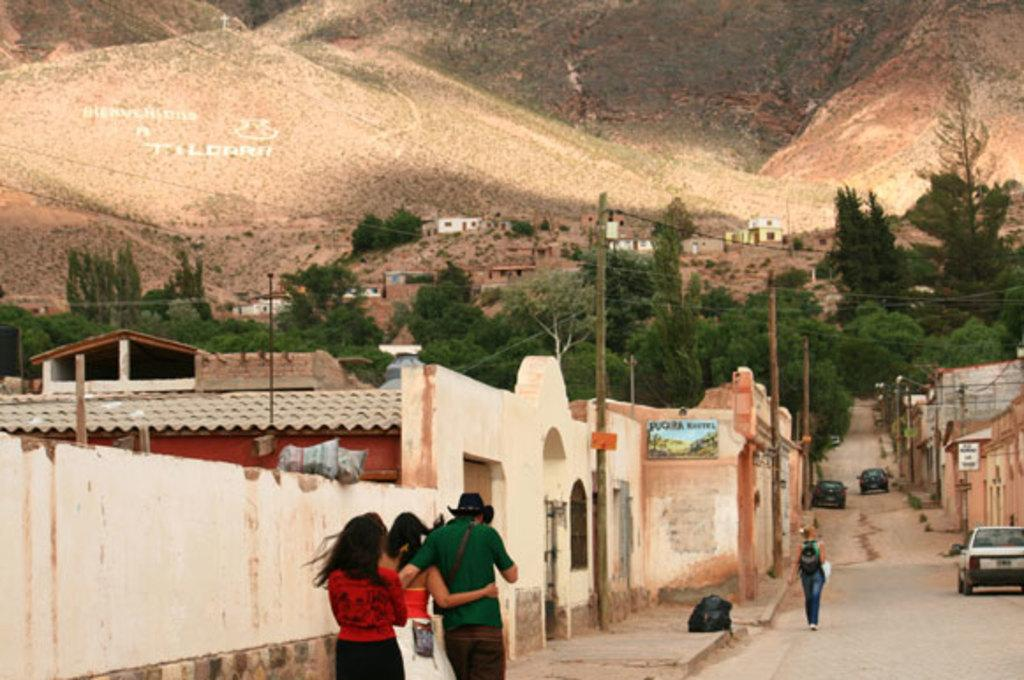What are the people in the image doing? The people in the image are walking. What else can be seen on the road in the image? There are cars on the road in the image. What can be seen in the distance in the image? There are buildings, trees, and hills visible in the background of the image. What structures are present in the image? There are poles in the image. What type of glue is being used to hold the engine together in the image? There is no engine or glue present in the image; it features people walking, cars on the road, and various structures in the background. 